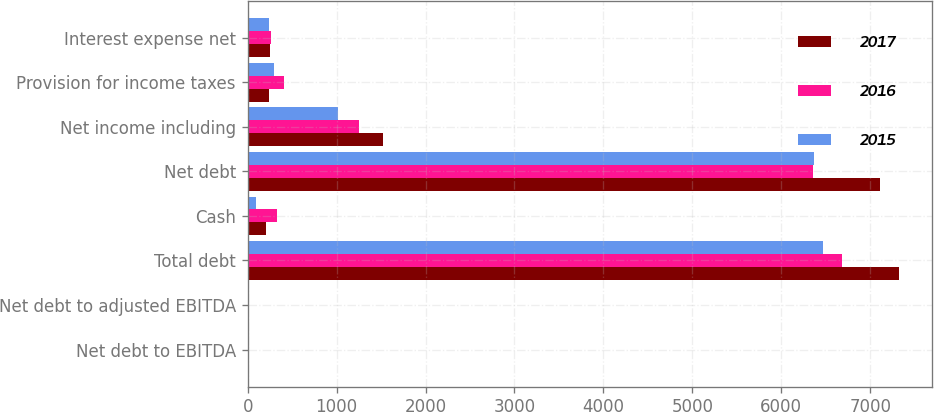Convert chart to OTSL. <chart><loc_0><loc_0><loc_500><loc_500><stacked_bar_chart><ecel><fcel>Net debt to EBITDA<fcel>Net debt to adjusted EBITDA<fcel>Total debt<fcel>Cash<fcel>Net debt<fcel>Net income including<fcel>Provision for income taxes<fcel>Interest expense net<nl><fcel>2017<fcel>2.4<fcel>2.4<fcel>7322.7<fcel>211.4<fcel>7111.3<fcel>1522.4<fcel>242.4<fcel>255<nl><fcel>2016<fcel>2.3<fcel>2.2<fcel>6687<fcel>327.4<fcel>6359.6<fcel>1247.1<fcel>403.3<fcel>264.6<nl><fcel>2015<fcel>2.6<fcel>2.2<fcel>6465.5<fcel>92.8<fcel>6372.7<fcel>1017.2<fcel>300.5<fcel>243.6<nl></chart> 